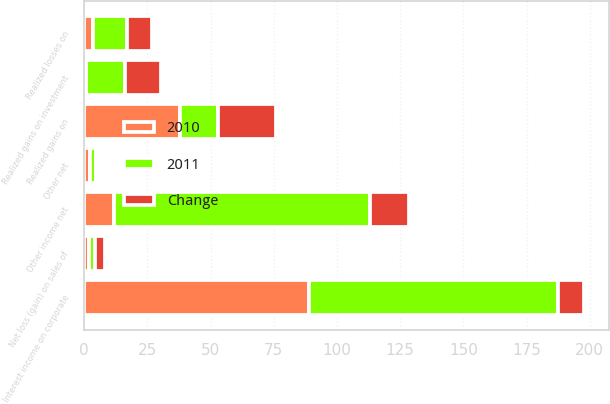Convert chart. <chart><loc_0><loc_0><loc_500><loc_500><stacked_bar_chart><ecel><fcel>Interest income on corporate<fcel>Realized gains on<fcel>Realized losses on<fcel>Realized gains on investment<fcel>Net loss (gain) on sales of<fcel>Other net<fcel>Other income net<nl><fcel>2010<fcel>88.8<fcel>38<fcel>3.6<fcel>0.9<fcel>1.8<fcel>2.4<fcel>11.7<nl><fcel>2011<fcel>98.8<fcel>15<fcel>13.4<fcel>15.2<fcel>2.3<fcel>2.3<fcel>101.2<nl><fcel>Change<fcel>10<fcel>23<fcel>9.8<fcel>14.3<fcel>4.1<fcel>0.1<fcel>15.4<nl></chart> 